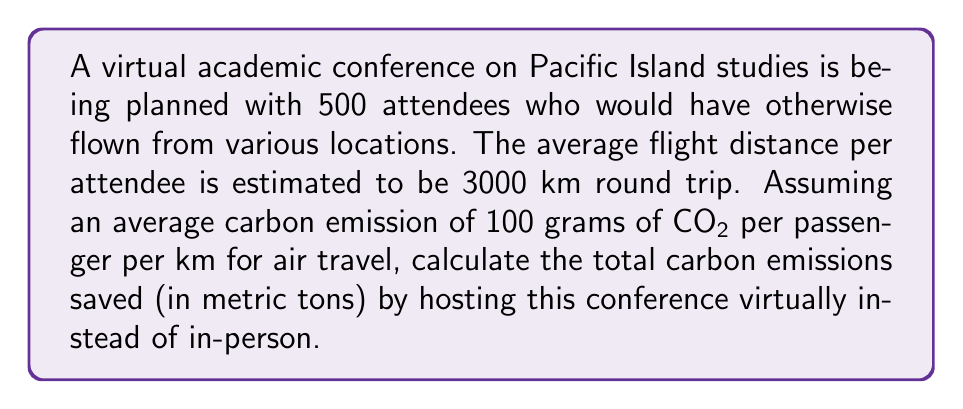Teach me how to tackle this problem. To solve this problem, we'll follow these steps:

1. Calculate the total distance traveled by all attendees:
   $$ \text{Total distance} = 500 \text{ attendees} \times 3000 \text{ km} = 1,500,000 \text{ km} $$

2. Calculate the total carbon emissions for this travel:
   $$ \text{Carbon emissions} = 1,500,000 \text{ km} \times 100 \text{ g CO}_2\text{/km} = 150,000,000 \text{ g CO}_2 $$

3. Convert grams to metric tons:
   $$ 150,000,000 \text{ g} = 150,000 \text{ kg} = 150 \text{ metric tons} $$

Therefore, by hosting the conference virtually, approximately 150 metric tons of CO2 emissions are saved.
Answer: 150 metric tons 